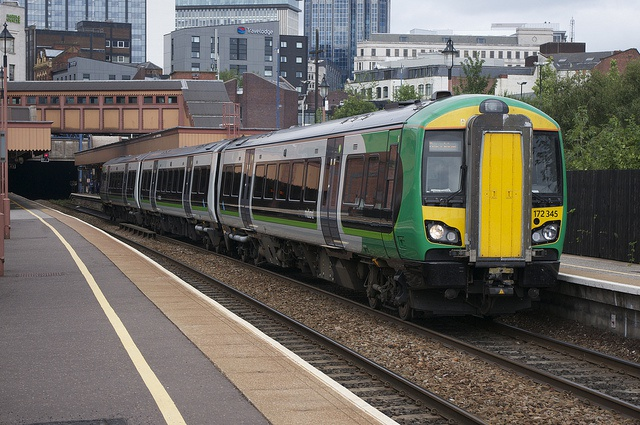Describe the objects in this image and their specific colors. I can see train in gray, black, darkgray, and gold tones and traffic light in gray, black, and purple tones in this image. 